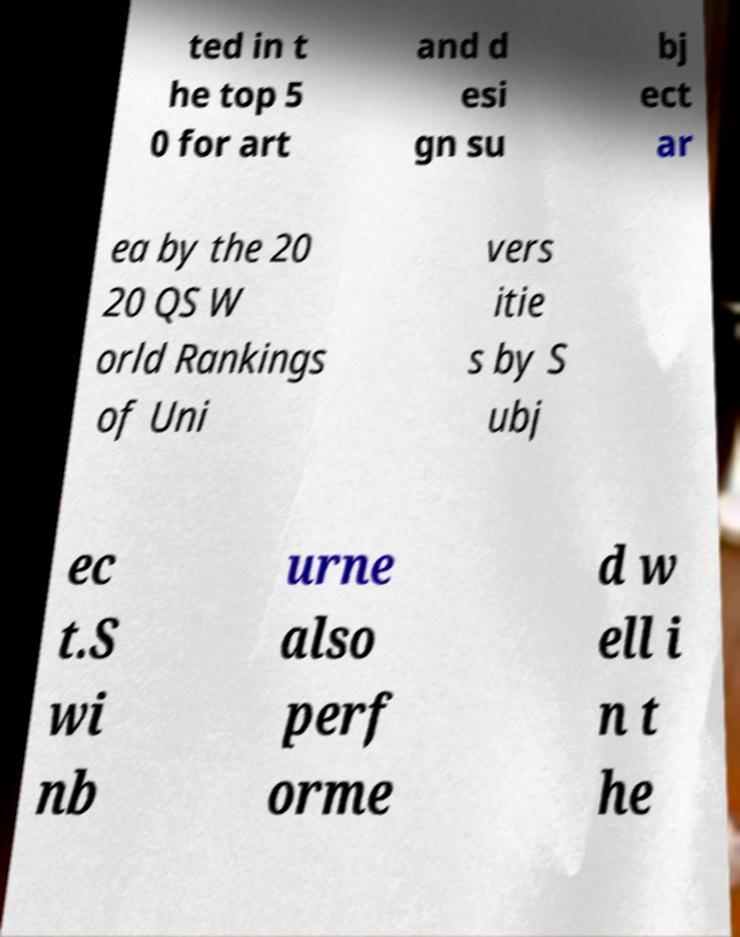Can you read and provide the text displayed in the image?This photo seems to have some interesting text. Can you extract and type it out for me? ted in t he top 5 0 for art and d esi gn su bj ect ar ea by the 20 20 QS W orld Rankings of Uni vers itie s by S ubj ec t.S wi nb urne also perf orme d w ell i n t he 